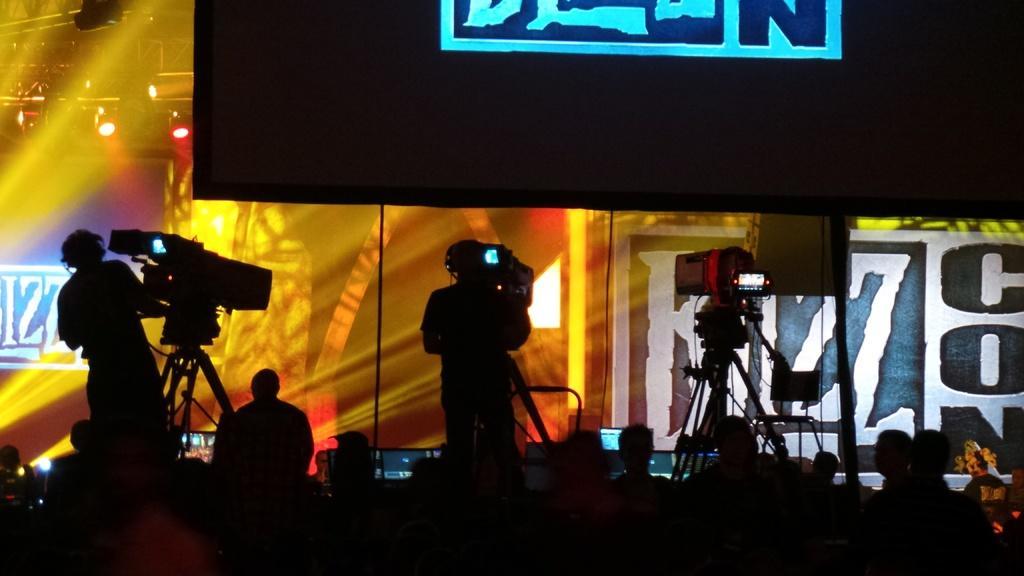Can you describe this image briefly? In this image we can see few persons at the bottom and the image is dark and there are persons standing on the platforms at the stands and on the stands we can see cameras. In the background there are lights on the poles, boards and objects. 